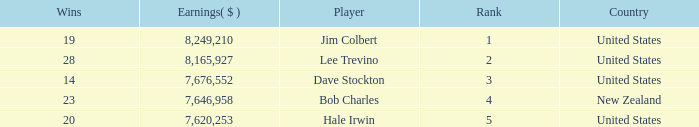How much have players earned with 14 wins ranked below 3? 0.0. 